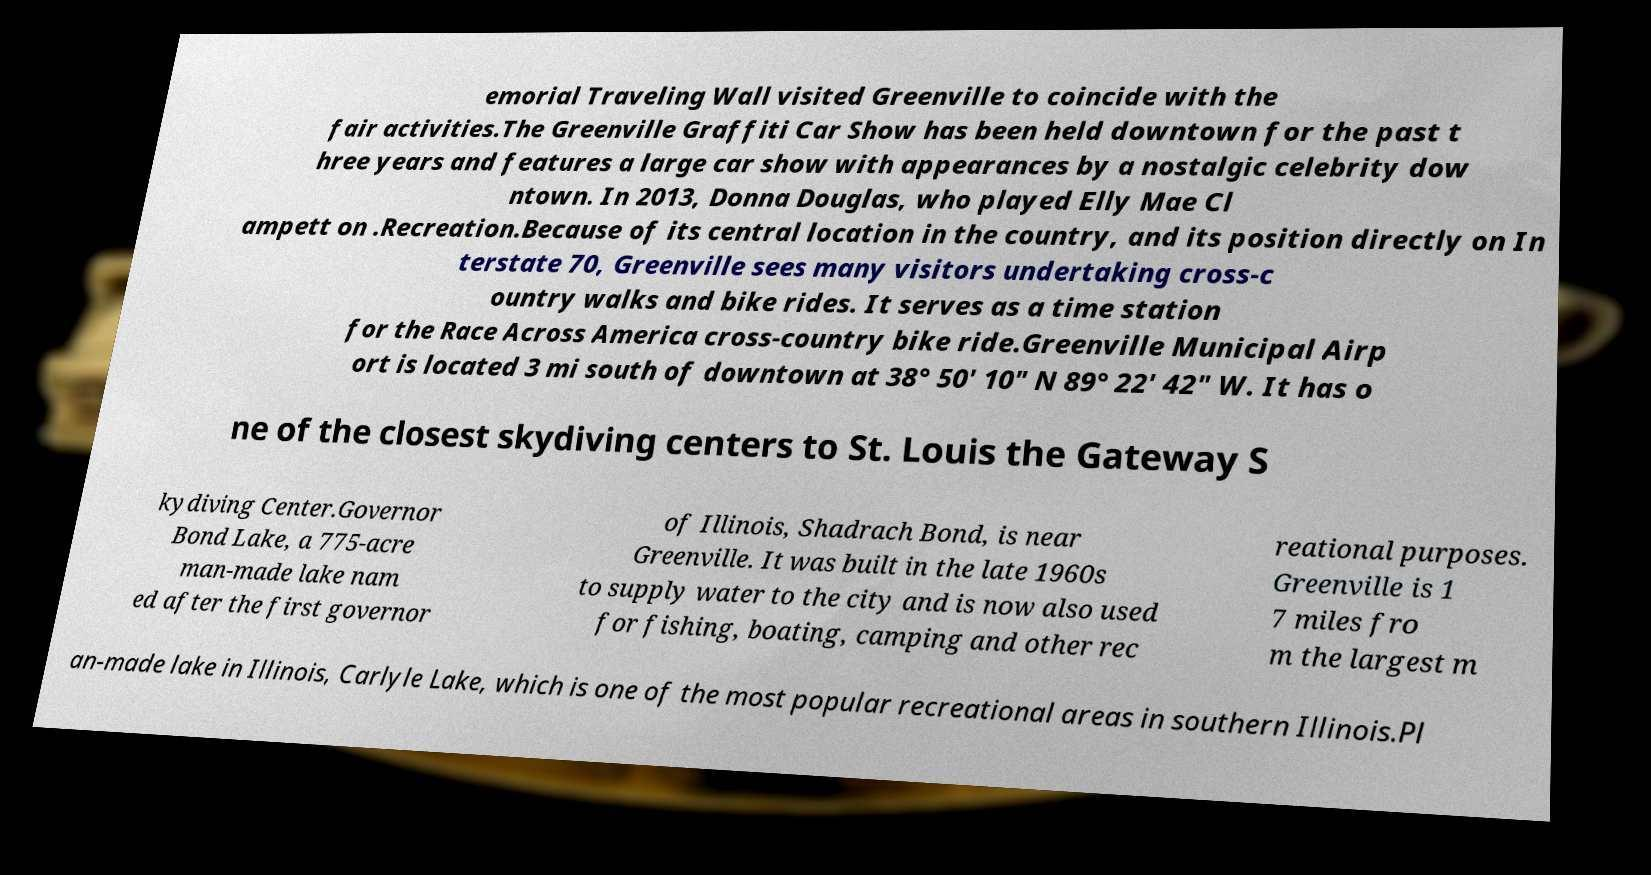Can you accurately transcribe the text from the provided image for me? emorial Traveling Wall visited Greenville to coincide with the fair activities.The Greenville Graffiti Car Show has been held downtown for the past t hree years and features a large car show with appearances by a nostalgic celebrity dow ntown. In 2013, Donna Douglas, who played Elly Mae Cl ampett on .Recreation.Because of its central location in the country, and its position directly on In terstate 70, Greenville sees many visitors undertaking cross-c ountry walks and bike rides. It serves as a time station for the Race Across America cross-country bike ride.Greenville Municipal Airp ort is located 3 mi south of downtown at 38° 50′ 10″ N 89° 22′ 42″ W. It has o ne of the closest skydiving centers to St. Louis the Gateway S kydiving Center.Governor Bond Lake, a 775-acre man-made lake nam ed after the first governor of Illinois, Shadrach Bond, is near Greenville. It was built in the late 1960s to supply water to the city and is now also used for fishing, boating, camping and other rec reational purposes. Greenville is 1 7 miles fro m the largest m an-made lake in Illinois, Carlyle Lake, which is one of the most popular recreational areas in southern Illinois.Pl 